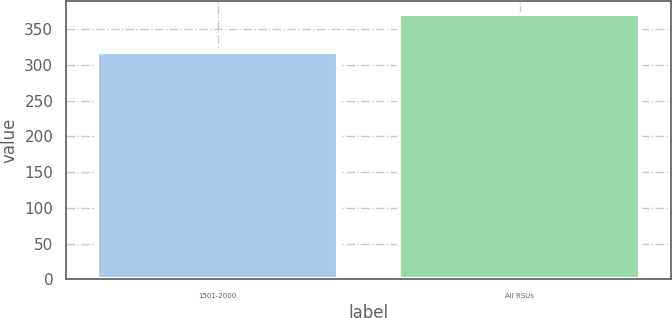<chart> <loc_0><loc_0><loc_500><loc_500><bar_chart><fcel>1501-2000<fcel>All RSUs<nl><fcel>318<fcel>371<nl></chart> 